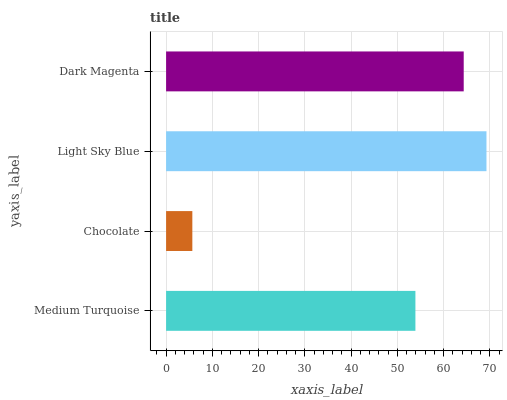Is Chocolate the minimum?
Answer yes or no. Yes. Is Light Sky Blue the maximum?
Answer yes or no. Yes. Is Light Sky Blue the minimum?
Answer yes or no. No. Is Chocolate the maximum?
Answer yes or no. No. Is Light Sky Blue greater than Chocolate?
Answer yes or no. Yes. Is Chocolate less than Light Sky Blue?
Answer yes or no. Yes. Is Chocolate greater than Light Sky Blue?
Answer yes or no. No. Is Light Sky Blue less than Chocolate?
Answer yes or no. No. Is Dark Magenta the high median?
Answer yes or no. Yes. Is Medium Turquoise the low median?
Answer yes or no. Yes. Is Chocolate the high median?
Answer yes or no. No. Is Light Sky Blue the low median?
Answer yes or no. No. 